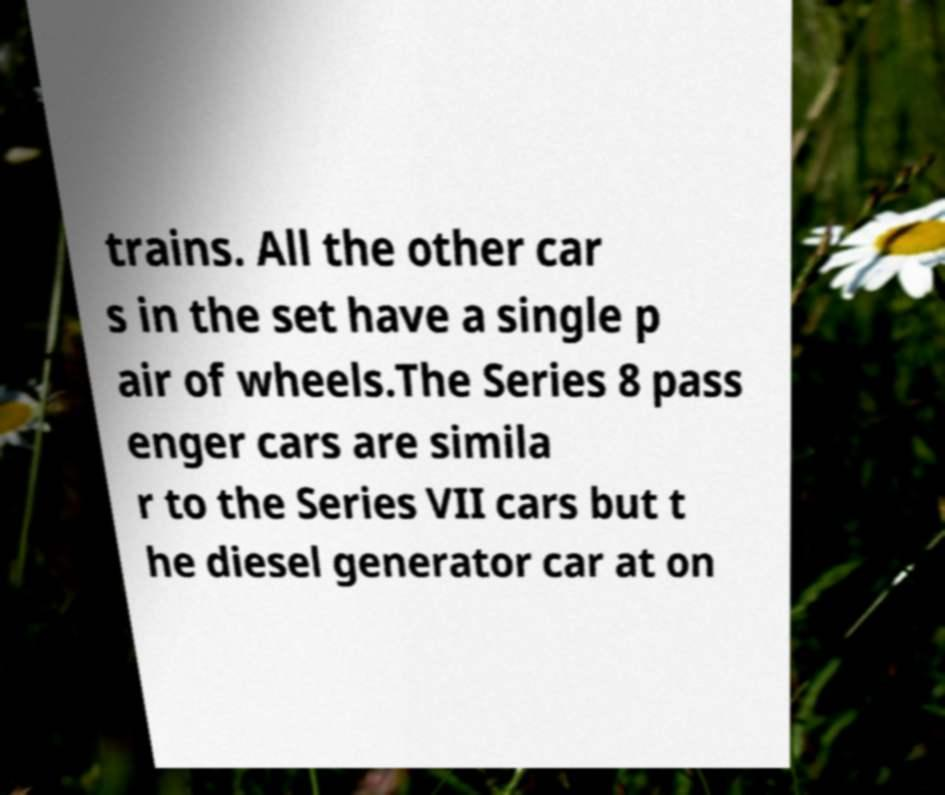Please read and relay the text visible in this image. What does it say? trains. All the other car s in the set have a single p air of wheels.The Series 8 pass enger cars are simila r to the Series VII cars but t he diesel generator car at on 